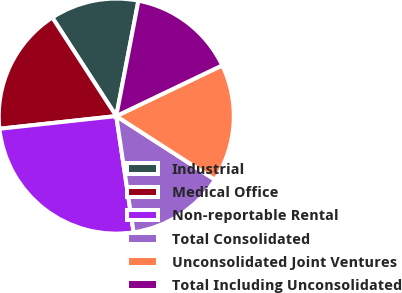Convert chart to OTSL. <chart><loc_0><loc_0><loc_500><loc_500><pie_chart><fcel>Industrial<fcel>Medical Office<fcel>Non-reportable Rental<fcel>Total Consolidated<fcel>Unconsolidated Joint Ventures<fcel>Total Including Unconsolidated<nl><fcel>12.18%<fcel>17.56%<fcel>25.63%<fcel>13.53%<fcel>16.22%<fcel>14.87%<nl></chart> 